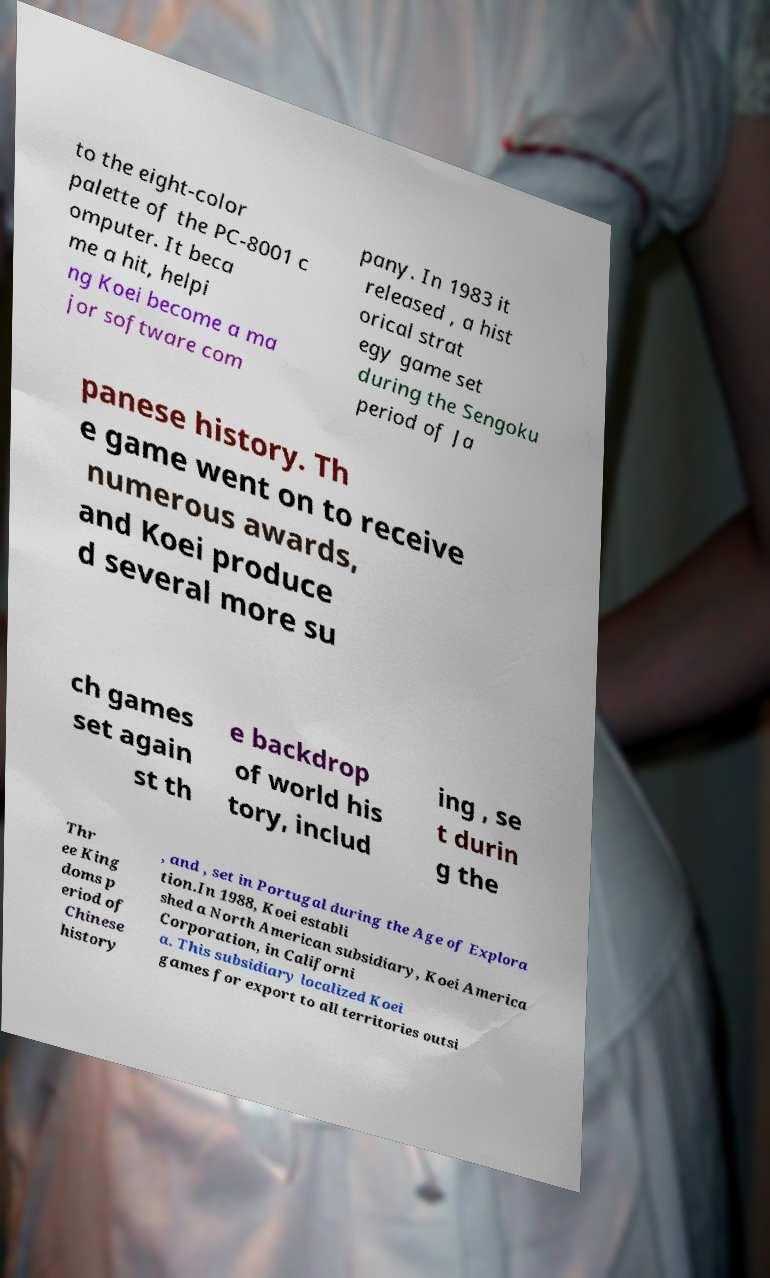Please read and relay the text visible in this image. What does it say? to the eight-color palette of the PC-8001 c omputer. It beca me a hit, helpi ng Koei become a ma jor software com pany. In 1983 it released , a hist orical strat egy game set during the Sengoku period of Ja panese history. Th e game went on to receive numerous awards, and Koei produce d several more su ch games set again st th e backdrop of world his tory, includ ing , se t durin g the Thr ee King doms p eriod of Chinese history , and , set in Portugal during the Age of Explora tion.In 1988, Koei establi shed a North American subsidiary, Koei America Corporation, in Californi a. This subsidiary localized Koei games for export to all territories outsi 